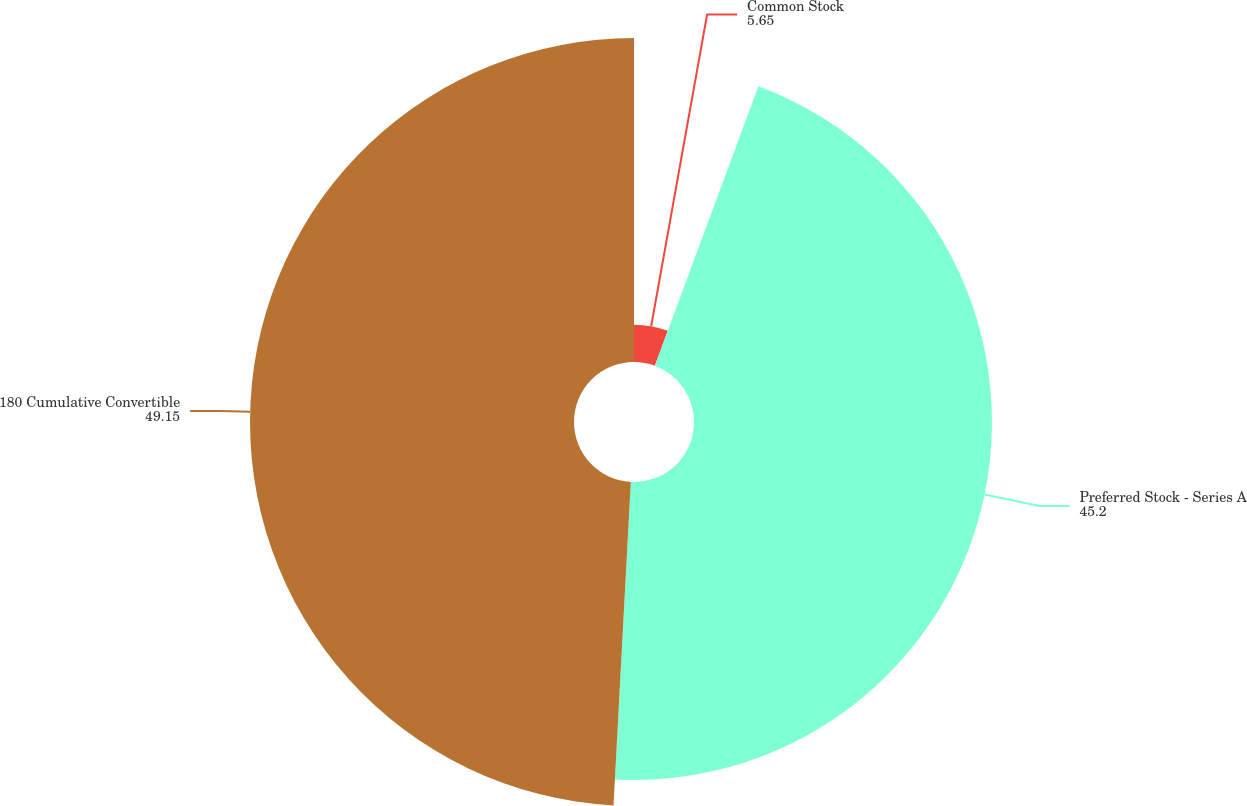<chart> <loc_0><loc_0><loc_500><loc_500><pie_chart><fcel>Common Stock<fcel>Preferred Stock - Series A<fcel>180 Cumulative Convertible<nl><fcel>5.65%<fcel>45.2%<fcel>49.15%<nl></chart> 